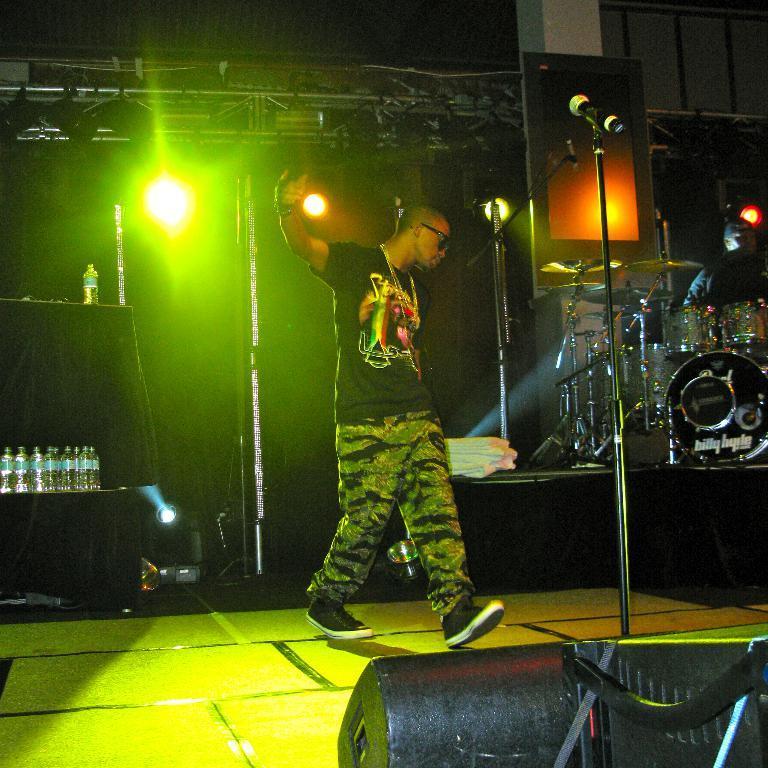In one or two sentences, can you explain what this image depicts? In this picture I can see a man standing, there are mikes with the mikes stands, there are drums, cymbals with the cymbals stands, there is another person, there are water bottles, speakers, lighting truss and there are focus lights. 